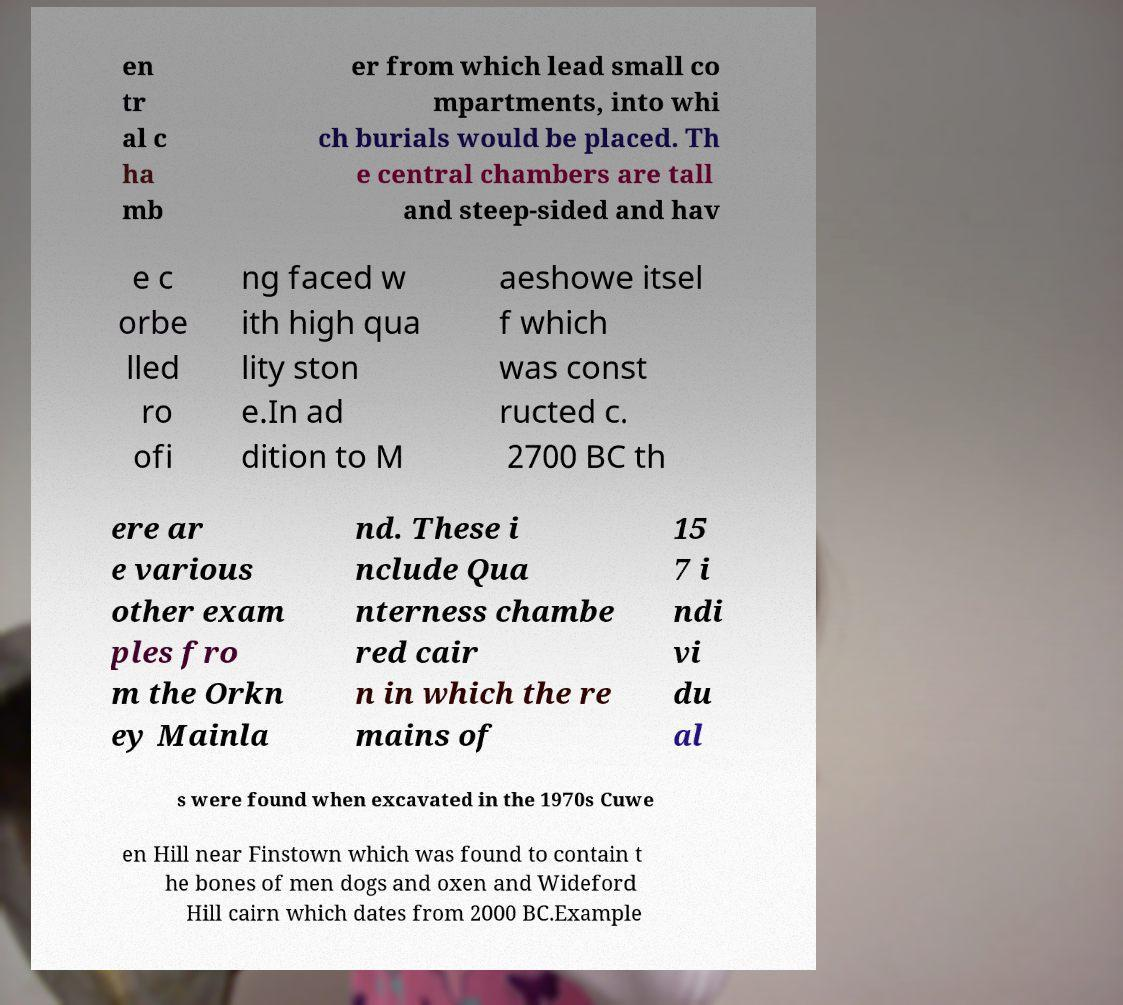Please identify and transcribe the text found in this image. en tr al c ha mb er from which lead small co mpartments, into whi ch burials would be placed. Th e central chambers are tall and steep-sided and hav e c orbe lled ro ofi ng faced w ith high qua lity ston e.In ad dition to M aeshowe itsel f which was const ructed c. 2700 BC th ere ar e various other exam ples fro m the Orkn ey Mainla nd. These i nclude Qua nterness chambe red cair n in which the re mains of 15 7 i ndi vi du al s were found when excavated in the 1970s Cuwe en Hill near Finstown which was found to contain t he bones of men dogs and oxen and Wideford Hill cairn which dates from 2000 BC.Example 